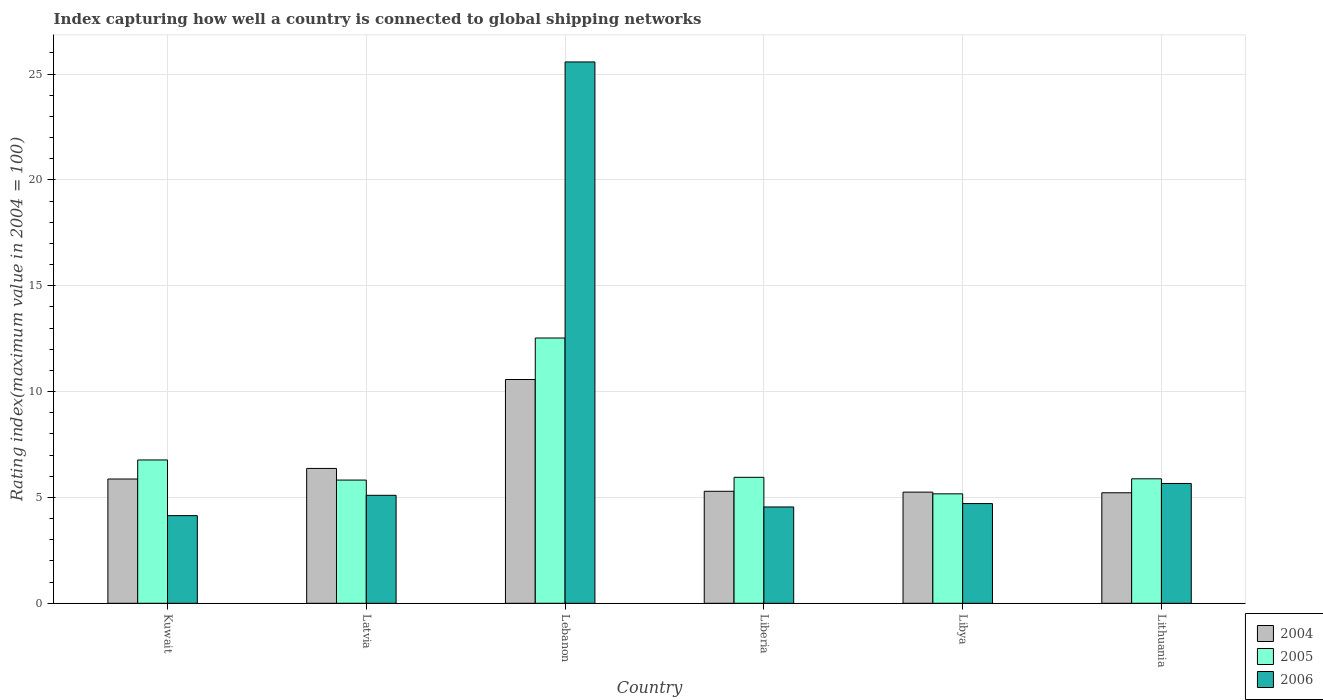How many different coloured bars are there?
Provide a short and direct response. 3. How many bars are there on the 1st tick from the left?
Make the answer very short. 3. What is the label of the 5th group of bars from the left?
Provide a short and direct response. Libya. In how many cases, is the number of bars for a given country not equal to the number of legend labels?
Give a very brief answer. 0. What is the rating index in 2005 in Lithuania?
Your answer should be compact. 5.88. Across all countries, what is the maximum rating index in 2006?
Your answer should be very brief. 25.57. Across all countries, what is the minimum rating index in 2006?
Give a very brief answer. 4.14. In which country was the rating index in 2006 maximum?
Give a very brief answer. Lebanon. In which country was the rating index in 2004 minimum?
Provide a short and direct response. Lithuania. What is the total rating index in 2004 in the graph?
Your answer should be very brief. 38.57. What is the difference between the rating index in 2004 in Kuwait and that in Lithuania?
Provide a succinct answer. 0.65. What is the difference between the rating index in 2004 in Lithuania and the rating index in 2005 in Lebanon?
Keep it short and to the point. -7.31. What is the average rating index in 2005 per country?
Offer a terse response. 7.02. What is the difference between the rating index of/in 2005 and rating index of/in 2006 in Liberia?
Your response must be concise. 1.4. What is the ratio of the rating index in 2006 in Kuwait to that in Latvia?
Ensure brevity in your answer.  0.81. What is the difference between the highest and the lowest rating index in 2005?
Offer a terse response. 7.36. In how many countries, is the rating index in 2004 greater than the average rating index in 2004 taken over all countries?
Provide a short and direct response. 1. Is the sum of the rating index in 2004 in Kuwait and Lebanon greater than the maximum rating index in 2005 across all countries?
Offer a terse response. Yes. What does the 3rd bar from the right in Latvia represents?
Your answer should be compact. 2004. How many bars are there?
Keep it short and to the point. 18. Are all the bars in the graph horizontal?
Your response must be concise. No. What is the difference between two consecutive major ticks on the Y-axis?
Keep it short and to the point. 5. Are the values on the major ticks of Y-axis written in scientific E-notation?
Offer a very short reply. No. How many legend labels are there?
Offer a very short reply. 3. What is the title of the graph?
Offer a very short reply. Index capturing how well a country is connected to global shipping networks. What is the label or title of the Y-axis?
Keep it short and to the point. Rating index(maximum value in 2004 = 100). What is the Rating index(maximum value in 2004 = 100) in 2004 in Kuwait?
Your answer should be compact. 5.87. What is the Rating index(maximum value in 2004 = 100) of 2005 in Kuwait?
Your answer should be very brief. 6.77. What is the Rating index(maximum value in 2004 = 100) of 2006 in Kuwait?
Ensure brevity in your answer.  4.14. What is the Rating index(maximum value in 2004 = 100) in 2004 in Latvia?
Your answer should be very brief. 6.37. What is the Rating index(maximum value in 2004 = 100) in 2005 in Latvia?
Your answer should be very brief. 5.82. What is the Rating index(maximum value in 2004 = 100) in 2004 in Lebanon?
Offer a terse response. 10.57. What is the Rating index(maximum value in 2004 = 100) in 2005 in Lebanon?
Offer a very short reply. 12.53. What is the Rating index(maximum value in 2004 = 100) of 2006 in Lebanon?
Your answer should be very brief. 25.57. What is the Rating index(maximum value in 2004 = 100) in 2004 in Liberia?
Offer a very short reply. 5.29. What is the Rating index(maximum value in 2004 = 100) of 2005 in Liberia?
Provide a short and direct response. 5.95. What is the Rating index(maximum value in 2004 = 100) of 2006 in Liberia?
Your answer should be very brief. 4.55. What is the Rating index(maximum value in 2004 = 100) of 2004 in Libya?
Ensure brevity in your answer.  5.25. What is the Rating index(maximum value in 2004 = 100) of 2005 in Libya?
Offer a terse response. 5.17. What is the Rating index(maximum value in 2004 = 100) in 2006 in Libya?
Provide a short and direct response. 4.71. What is the Rating index(maximum value in 2004 = 100) of 2004 in Lithuania?
Give a very brief answer. 5.22. What is the Rating index(maximum value in 2004 = 100) in 2005 in Lithuania?
Offer a very short reply. 5.88. What is the Rating index(maximum value in 2004 = 100) of 2006 in Lithuania?
Ensure brevity in your answer.  5.66. Across all countries, what is the maximum Rating index(maximum value in 2004 = 100) in 2004?
Provide a short and direct response. 10.57. Across all countries, what is the maximum Rating index(maximum value in 2004 = 100) of 2005?
Ensure brevity in your answer.  12.53. Across all countries, what is the maximum Rating index(maximum value in 2004 = 100) of 2006?
Your answer should be compact. 25.57. Across all countries, what is the minimum Rating index(maximum value in 2004 = 100) in 2004?
Your answer should be very brief. 5.22. Across all countries, what is the minimum Rating index(maximum value in 2004 = 100) of 2005?
Offer a terse response. 5.17. Across all countries, what is the minimum Rating index(maximum value in 2004 = 100) of 2006?
Ensure brevity in your answer.  4.14. What is the total Rating index(maximum value in 2004 = 100) in 2004 in the graph?
Keep it short and to the point. 38.57. What is the total Rating index(maximum value in 2004 = 100) of 2005 in the graph?
Your answer should be very brief. 42.12. What is the total Rating index(maximum value in 2004 = 100) of 2006 in the graph?
Your response must be concise. 49.73. What is the difference between the Rating index(maximum value in 2004 = 100) of 2005 in Kuwait and that in Latvia?
Your answer should be compact. 0.95. What is the difference between the Rating index(maximum value in 2004 = 100) in 2006 in Kuwait and that in Latvia?
Offer a terse response. -0.96. What is the difference between the Rating index(maximum value in 2004 = 100) of 2004 in Kuwait and that in Lebanon?
Give a very brief answer. -4.7. What is the difference between the Rating index(maximum value in 2004 = 100) of 2005 in Kuwait and that in Lebanon?
Give a very brief answer. -5.76. What is the difference between the Rating index(maximum value in 2004 = 100) of 2006 in Kuwait and that in Lebanon?
Give a very brief answer. -21.43. What is the difference between the Rating index(maximum value in 2004 = 100) in 2004 in Kuwait and that in Liberia?
Keep it short and to the point. 0.58. What is the difference between the Rating index(maximum value in 2004 = 100) of 2005 in Kuwait and that in Liberia?
Offer a very short reply. 0.82. What is the difference between the Rating index(maximum value in 2004 = 100) of 2006 in Kuwait and that in Liberia?
Make the answer very short. -0.41. What is the difference between the Rating index(maximum value in 2004 = 100) in 2004 in Kuwait and that in Libya?
Offer a very short reply. 0.62. What is the difference between the Rating index(maximum value in 2004 = 100) of 2005 in Kuwait and that in Libya?
Your response must be concise. 1.6. What is the difference between the Rating index(maximum value in 2004 = 100) of 2006 in Kuwait and that in Libya?
Ensure brevity in your answer.  -0.57. What is the difference between the Rating index(maximum value in 2004 = 100) of 2004 in Kuwait and that in Lithuania?
Offer a terse response. 0.65. What is the difference between the Rating index(maximum value in 2004 = 100) in 2005 in Kuwait and that in Lithuania?
Offer a terse response. 0.89. What is the difference between the Rating index(maximum value in 2004 = 100) of 2006 in Kuwait and that in Lithuania?
Offer a very short reply. -1.52. What is the difference between the Rating index(maximum value in 2004 = 100) of 2005 in Latvia and that in Lebanon?
Your answer should be compact. -6.71. What is the difference between the Rating index(maximum value in 2004 = 100) of 2006 in Latvia and that in Lebanon?
Offer a terse response. -20.47. What is the difference between the Rating index(maximum value in 2004 = 100) of 2005 in Latvia and that in Liberia?
Offer a terse response. -0.13. What is the difference between the Rating index(maximum value in 2004 = 100) of 2006 in Latvia and that in Liberia?
Your response must be concise. 0.55. What is the difference between the Rating index(maximum value in 2004 = 100) in 2004 in Latvia and that in Libya?
Your answer should be very brief. 1.12. What is the difference between the Rating index(maximum value in 2004 = 100) of 2005 in Latvia and that in Libya?
Your answer should be very brief. 0.65. What is the difference between the Rating index(maximum value in 2004 = 100) in 2006 in Latvia and that in Libya?
Your answer should be compact. 0.39. What is the difference between the Rating index(maximum value in 2004 = 100) of 2004 in Latvia and that in Lithuania?
Your response must be concise. 1.15. What is the difference between the Rating index(maximum value in 2004 = 100) of 2005 in Latvia and that in Lithuania?
Your response must be concise. -0.06. What is the difference between the Rating index(maximum value in 2004 = 100) of 2006 in Latvia and that in Lithuania?
Provide a short and direct response. -0.56. What is the difference between the Rating index(maximum value in 2004 = 100) in 2004 in Lebanon and that in Liberia?
Keep it short and to the point. 5.28. What is the difference between the Rating index(maximum value in 2004 = 100) in 2005 in Lebanon and that in Liberia?
Your response must be concise. 6.58. What is the difference between the Rating index(maximum value in 2004 = 100) in 2006 in Lebanon and that in Liberia?
Your response must be concise. 21.02. What is the difference between the Rating index(maximum value in 2004 = 100) of 2004 in Lebanon and that in Libya?
Give a very brief answer. 5.32. What is the difference between the Rating index(maximum value in 2004 = 100) in 2005 in Lebanon and that in Libya?
Your response must be concise. 7.36. What is the difference between the Rating index(maximum value in 2004 = 100) of 2006 in Lebanon and that in Libya?
Ensure brevity in your answer.  20.86. What is the difference between the Rating index(maximum value in 2004 = 100) of 2004 in Lebanon and that in Lithuania?
Provide a succinct answer. 5.35. What is the difference between the Rating index(maximum value in 2004 = 100) in 2005 in Lebanon and that in Lithuania?
Your response must be concise. 6.65. What is the difference between the Rating index(maximum value in 2004 = 100) in 2006 in Lebanon and that in Lithuania?
Your answer should be very brief. 19.91. What is the difference between the Rating index(maximum value in 2004 = 100) of 2005 in Liberia and that in Libya?
Keep it short and to the point. 0.78. What is the difference between the Rating index(maximum value in 2004 = 100) in 2006 in Liberia and that in Libya?
Your answer should be very brief. -0.16. What is the difference between the Rating index(maximum value in 2004 = 100) of 2004 in Liberia and that in Lithuania?
Offer a very short reply. 0.07. What is the difference between the Rating index(maximum value in 2004 = 100) in 2005 in Liberia and that in Lithuania?
Offer a terse response. 0.07. What is the difference between the Rating index(maximum value in 2004 = 100) of 2006 in Liberia and that in Lithuania?
Provide a succinct answer. -1.11. What is the difference between the Rating index(maximum value in 2004 = 100) in 2005 in Libya and that in Lithuania?
Ensure brevity in your answer.  -0.71. What is the difference between the Rating index(maximum value in 2004 = 100) in 2006 in Libya and that in Lithuania?
Offer a terse response. -0.95. What is the difference between the Rating index(maximum value in 2004 = 100) in 2004 in Kuwait and the Rating index(maximum value in 2004 = 100) in 2005 in Latvia?
Ensure brevity in your answer.  0.05. What is the difference between the Rating index(maximum value in 2004 = 100) of 2004 in Kuwait and the Rating index(maximum value in 2004 = 100) of 2006 in Latvia?
Your response must be concise. 0.77. What is the difference between the Rating index(maximum value in 2004 = 100) in 2005 in Kuwait and the Rating index(maximum value in 2004 = 100) in 2006 in Latvia?
Your response must be concise. 1.67. What is the difference between the Rating index(maximum value in 2004 = 100) of 2004 in Kuwait and the Rating index(maximum value in 2004 = 100) of 2005 in Lebanon?
Give a very brief answer. -6.66. What is the difference between the Rating index(maximum value in 2004 = 100) of 2004 in Kuwait and the Rating index(maximum value in 2004 = 100) of 2006 in Lebanon?
Your answer should be compact. -19.7. What is the difference between the Rating index(maximum value in 2004 = 100) in 2005 in Kuwait and the Rating index(maximum value in 2004 = 100) in 2006 in Lebanon?
Provide a succinct answer. -18.8. What is the difference between the Rating index(maximum value in 2004 = 100) in 2004 in Kuwait and the Rating index(maximum value in 2004 = 100) in 2005 in Liberia?
Give a very brief answer. -0.08. What is the difference between the Rating index(maximum value in 2004 = 100) of 2004 in Kuwait and the Rating index(maximum value in 2004 = 100) of 2006 in Liberia?
Offer a terse response. 1.32. What is the difference between the Rating index(maximum value in 2004 = 100) of 2005 in Kuwait and the Rating index(maximum value in 2004 = 100) of 2006 in Liberia?
Give a very brief answer. 2.22. What is the difference between the Rating index(maximum value in 2004 = 100) of 2004 in Kuwait and the Rating index(maximum value in 2004 = 100) of 2006 in Libya?
Provide a short and direct response. 1.16. What is the difference between the Rating index(maximum value in 2004 = 100) of 2005 in Kuwait and the Rating index(maximum value in 2004 = 100) of 2006 in Libya?
Provide a short and direct response. 2.06. What is the difference between the Rating index(maximum value in 2004 = 100) of 2004 in Kuwait and the Rating index(maximum value in 2004 = 100) of 2005 in Lithuania?
Keep it short and to the point. -0.01. What is the difference between the Rating index(maximum value in 2004 = 100) in 2004 in Kuwait and the Rating index(maximum value in 2004 = 100) in 2006 in Lithuania?
Provide a succinct answer. 0.21. What is the difference between the Rating index(maximum value in 2004 = 100) in 2005 in Kuwait and the Rating index(maximum value in 2004 = 100) in 2006 in Lithuania?
Ensure brevity in your answer.  1.11. What is the difference between the Rating index(maximum value in 2004 = 100) of 2004 in Latvia and the Rating index(maximum value in 2004 = 100) of 2005 in Lebanon?
Keep it short and to the point. -6.16. What is the difference between the Rating index(maximum value in 2004 = 100) of 2004 in Latvia and the Rating index(maximum value in 2004 = 100) of 2006 in Lebanon?
Provide a succinct answer. -19.2. What is the difference between the Rating index(maximum value in 2004 = 100) of 2005 in Latvia and the Rating index(maximum value in 2004 = 100) of 2006 in Lebanon?
Keep it short and to the point. -19.75. What is the difference between the Rating index(maximum value in 2004 = 100) in 2004 in Latvia and the Rating index(maximum value in 2004 = 100) in 2005 in Liberia?
Provide a short and direct response. 0.42. What is the difference between the Rating index(maximum value in 2004 = 100) in 2004 in Latvia and the Rating index(maximum value in 2004 = 100) in 2006 in Liberia?
Offer a terse response. 1.82. What is the difference between the Rating index(maximum value in 2004 = 100) of 2005 in Latvia and the Rating index(maximum value in 2004 = 100) of 2006 in Liberia?
Offer a terse response. 1.27. What is the difference between the Rating index(maximum value in 2004 = 100) of 2004 in Latvia and the Rating index(maximum value in 2004 = 100) of 2006 in Libya?
Provide a short and direct response. 1.66. What is the difference between the Rating index(maximum value in 2004 = 100) in 2005 in Latvia and the Rating index(maximum value in 2004 = 100) in 2006 in Libya?
Provide a short and direct response. 1.11. What is the difference between the Rating index(maximum value in 2004 = 100) of 2004 in Latvia and the Rating index(maximum value in 2004 = 100) of 2005 in Lithuania?
Make the answer very short. 0.49. What is the difference between the Rating index(maximum value in 2004 = 100) of 2004 in Latvia and the Rating index(maximum value in 2004 = 100) of 2006 in Lithuania?
Provide a succinct answer. 0.71. What is the difference between the Rating index(maximum value in 2004 = 100) in 2005 in Latvia and the Rating index(maximum value in 2004 = 100) in 2006 in Lithuania?
Offer a very short reply. 0.16. What is the difference between the Rating index(maximum value in 2004 = 100) of 2004 in Lebanon and the Rating index(maximum value in 2004 = 100) of 2005 in Liberia?
Make the answer very short. 4.62. What is the difference between the Rating index(maximum value in 2004 = 100) in 2004 in Lebanon and the Rating index(maximum value in 2004 = 100) in 2006 in Liberia?
Your answer should be compact. 6.02. What is the difference between the Rating index(maximum value in 2004 = 100) of 2005 in Lebanon and the Rating index(maximum value in 2004 = 100) of 2006 in Liberia?
Make the answer very short. 7.98. What is the difference between the Rating index(maximum value in 2004 = 100) in 2004 in Lebanon and the Rating index(maximum value in 2004 = 100) in 2006 in Libya?
Provide a succinct answer. 5.86. What is the difference between the Rating index(maximum value in 2004 = 100) of 2005 in Lebanon and the Rating index(maximum value in 2004 = 100) of 2006 in Libya?
Ensure brevity in your answer.  7.82. What is the difference between the Rating index(maximum value in 2004 = 100) in 2004 in Lebanon and the Rating index(maximum value in 2004 = 100) in 2005 in Lithuania?
Provide a succinct answer. 4.69. What is the difference between the Rating index(maximum value in 2004 = 100) of 2004 in Lebanon and the Rating index(maximum value in 2004 = 100) of 2006 in Lithuania?
Your answer should be very brief. 4.91. What is the difference between the Rating index(maximum value in 2004 = 100) of 2005 in Lebanon and the Rating index(maximum value in 2004 = 100) of 2006 in Lithuania?
Give a very brief answer. 6.87. What is the difference between the Rating index(maximum value in 2004 = 100) in 2004 in Liberia and the Rating index(maximum value in 2004 = 100) in 2005 in Libya?
Your answer should be very brief. 0.12. What is the difference between the Rating index(maximum value in 2004 = 100) in 2004 in Liberia and the Rating index(maximum value in 2004 = 100) in 2006 in Libya?
Provide a short and direct response. 0.58. What is the difference between the Rating index(maximum value in 2004 = 100) of 2005 in Liberia and the Rating index(maximum value in 2004 = 100) of 2006 in Libya?
Keep it short and to the point. 1.24. What is the difference between the Rating index(maximum value in 2004 = 100) in 2004 in Liberia and the Rating index(maximum value in 2004 = 100) in 2005 in Lithuania?
Provide a succinct answer. -0.59. What is the difference between the Rating index(maximum value in 2004 = 100) in 2004 in Liberia and the Rating index(maximum value in 2004 = 100) in 2006 in Lithuania?
Ensure brevity in your answer.  -0.37. What is the difference between the Rating index(maximum value in 2004 = 100) in 2005 in Liberia and the Rating index(maximum value in 2004 = 100) in 2006 in Lithuania?
Make the answer very short. 0.29. What is the difference between the Rating index(maximum value in 2004 = 100) of 2004 in Libya and the Rating index(maximum value in 2004 = 100) of 2005 in Lithuania?
Make the answer very short. -0.63. What is the difference between the Rating index(maximum value in 2004 = 100) in 2004 in Libya and the Rating index(maximum value in 2004 = 100) in 2006 in Lithuania?
Offer a terse response. -0.41. What is the difference between the Rating index(maximum value in 2004 = 100) of 2005 in Libya and the Rating index(maximum value in 2004 = 100) of 2006 in Lithuania?
Provide a short and direct response. -0.49. What is the average Rating index(maximum value in 2004 = 100) in 2004 per country?
Provide a short and direct response. 6.43. What is the average Rating index(maximum value in 2004 = 100) of 2005 per country?
Provide a short and direct response. 7.02. What is the average Rating index(maximum value in 2004 = 100) in 2006 per country?
Ensure brevity in your answer.  8.29. What is the difference between the Rating index(maximum value in 2004 = 100) in 2004 and Rating index(maximum value in 2004 = 100) in 2006 in Kuwait?
Offer a terse response. 1.73. What is the difference between the Rating index(maximum value in 2004 = 100) in 2005 and Rating index(maximum value in 2004 = 100) in 2006 in Kuwait?
Your answer should be compact. 2.63. What is the difference between the Rating index(maximum value in 2004 = 100) in 2004 and Rating index(maximum value in 2004 = 100) in 2005 in Latvia?
Your response must be concise. 0.55. What is the difference between the Rating index(maximum value in 2004 = 100) of 2004 and Rating index(maximum value in 2004 = 100) of 2006 in Latvia?
Provide a succinct answer. 1.27. What is the difference between the Rating index(maximum value in 2004 = 100) in 2005 and Rating index(maximum value in 2004 = 100) in 2006 in Latvia?
Your answer should be compact. 0.72. What is the difference between the Rating index(maximum value in 2004 = 100) in 2004 and Rating index(maximum value in 2004 = 100) in 2005 in Lebanon?
Keep it short and to the point. -1.96. What is the difference between the Rating index(maximum value in 2004 = 100) in 2004 and Rating index(maximum value in 2004 = 100) in 2006 in Lebanon?
Your answer should be very brief. -15. What is the difference between the Rating index(maximum value in 2004 = 100) in 2005 and Rating index(maximum value in 2004 = 100) in 2006 in Lebanon?
Your answer should be very brief. -13.04. What is the difference between the Rating index(maximum value in 2004 = 100) of 2004 and Rating index(maximum value in 2004 = 100) of 2005 in Liberia?
Your answer should be very brief. -0.66. What is the difference between the Rating index(maximum value in 2004 = 100) of 2004 and Rating index(maximum value in 2004 = 100) of 2006 in Liberia?
Provide a succinct answer. 0.74. What is the difference between the Rating index(maximum value in 2004 = 100) of 2005 and Rating index(maximum value in 2004 = 100) of 2006 in Liberia?
Provide a short and direct response. 1.4. What is the difference between the Rating index(maximum value in 2004 = 100) of 2004 and Rating index(maximum value in 2004 = 100) of 2005 in Libya?
Ensure brevity in your answer.  0.08. What is the difference between the Rating index(maximum value in 2004 = 100) in 2004 and Rating index(maximum value in 2004 = 100) in 2006 in Libya?
Offer a very short reply. 0.54. What is the difference between the Rating index(maximum value in 2004 = 100) in 2005 and Rating index(maximum value in 2004 = 100) in 2006 in Libya?
Your response must be concise. 0.46. What is the difference between the Rating index(maximum value in 2004 = 100) of 2004 and Rating index(maximum value in 2004 = 100) of 2005 in Lithuania?
Make the answer very short. -0.66. What is the difference between the Rating index(maximum value in 2004 = 100) in 2004 and Rating index(maximum value in 2004 = 100) in 2006 in Lithuania?
Make the answer very short. -0.44. What is the difference between the Rating index(maximum value in 2004 = 100) of 2005 and Rating index(maximum value in 2004 = 100) of 2006 in Lithuania?
Offer a terse response. 0.22. What is the ratio of the Rating index(maximum value in 2004 = 100) of 2004 in Kuwait to that in Latvia?
Keep it short and to the point. 0.92. What is the ratio of the Rating index(maximum value in 2004 = 100) of 2005 in Kuwait to that in Latvia?
Ensure brevity in your answer.  1.16. What is the ratio of the Rating index(maximum value in 2004 = 100) in 2006 in Kuwait to that in Latvia?
Provide a short and direct response. 0.81. What is the ratio of the Rating index(maximum value in 2004 = 100) of 2004 in Kuwait to that in Lebanon?
Make the answer very short. 0.56. What is the ratio of the Rating index(maximum value in 2004 = 100) in 2005 in Kuwait to that in Lebanon?
Give a very brief answer. 0.54. What is the ratio of the Rating index(maximum value in 2004 = 100) in 2006 in Kuwait to that in Lebanon?
Your response must be concise. 0.16. What is the ratio of the Rating index(maximum value in 2004 = 100) of 2004 in Kuwait to that in Liberia?
Your answer should be compact. 1.11. What is the ratio of the Rating index(maximum value in 2004 = 100) of 2005 in Kuwait to that in Liberia?
Make the answer very short. 1.14. What is the ratio of the Rating index(maximum value in 2004 = 100) in 2006 in Kuwait to that in Liberia?
Your response must be concise. 0.91. What is the ratio of the Rating index(maximum value in 2004 = 100) of 2004 in Kuwait to that in Libya?
Provide a succinct answer. 1.12. What is the ratio of the Rating index(maximum value in 2004 = 100) in 2005 in Kuwait to that in Libya?
Your answer should be very brief. 1.31. What is the ratio of the Rating index(maximum value in 2004 = 100) of 2006 in Kuwait to that in Libya?
Keep it short and to the point. 0.88. What is the ratio of the Rating index(maximum value in 2004 = 100) of 2004 in Kuwait to that in Lithuania?
Give a very brief answer. 1.12. What is the ratio of the Rating index(maximum value in 2004 = 100) of 2005 in Kuwait to that in Lithuania?
Provide a succinct answer. 1.15. What is the ratio of the Rating index(maximum value in 2004 = 100) of 2006 in Kuwait to that in Lithuania?
Give a very brief answer. 0.73. What is the ratio of the Rating index(maximum value in 2004 = 100) in 2004 in Latvia to that in Lebanon?
Make the answer very short. 0.6. What is the ratio of the Rating index(maximum value in 2004 = 100) in 2005 in Latvia to that in Lebanon?
Keep it short and to the point. 0.46. What is the ratio of the Rating index(maximum value in 2004 = 100) of 2006 in Latvia to that in Lebanon?
Give a very brief answer. 0.2. What is the ratio of the Rating index(maximum value in 2004 = 100) of 2004 in Latvia to that in Liberia?
Ensure brevity in your answer.  1.2. What is the ratio of the Rating index(maximum value in 2004 = 100) in 2005 in Latvia to that in Liberia?
Your answer should be compact. 0.98. What is the ratio of the Rating index(maximum value in 2004 = 100) in 2006 in Latvia to that in Liberia?
Keep it short and to the point. 1.12. What is the ratio of the Rating index(maximum value in 2004 = 100) in 2004 in Latvia to that in Libya?
Your answer should be very brief. 1.21. What is the ratio of the Rating index(maximum value in 2004 = 100) of 2005 in Latvia to that in Libya?
Keep it short and to the point. 1.13. What is the ratio of the Rating index(maximum value in 2004 = 100) in 2006 in Latvia to that in Libya?
Your response must be concise. 1.08. What is the ratio of the Rating index(maximum value in 2004 = 100) of 2004 in Latvia to that in Lithuania?
Your response must be concise. 1.22. What is the ratio of the Rating index(maximum value in 2004 = 100) of 2006 in Latvia to that in Lithuania?
Offer a very short reply. 0.9. What is the ratio of the Rating index(maximum value in 2004 = 100) in 2004 in Lebanon to that in Liberia?
Offer a terse response. 2. What is the ratio of the Rating index(maximum value in 2004 = 100) of 2005 in Lebanon to that in Liberia?
Provide a short and direct response. 2.11. What is the ratio of the Rating index(maximum value in 2004 = 100) of 2006 in Lebanon to that in Liberia?
Your answer should be compact. 5.62. What is the ratio of the Rating index(maximum value in 2004 = 100) in 2004 in Lebanon to that in Libya?
Offer a very short reply. 2.01. What is the ratio of the Rating index(maximum value in 2004 = 100) in 2005 in Lebanon to that in Libya?
Your answer should be very brief. 2.42. What is the ratio of the Rating index(maximum value in 2004 = 100) in 2006 in Lebanon to that in Libya?
Make the answer very short. 5.43. What is the ratio of the Rating index(maximum value in 2004 = 100) in 2004 in Lebanon to that in Lithuania?
Ensure brevity in your answer.  2.02. What is the ratio of the Rating index(maximum value in 2004 = 100) of 2005 in Lebanon to that in Lithuania?
Keep it short and to the point. 2.13. What is the ratio of the Rating index(maximum value in 2004 = 100) in 2006 in Lebanon to that in Lithuania?
Your answer should be very brief. 4.52. What is the ratio of the Rating index(maximum value in 2004 = 100) of 2004 in Liberia to that in Libya?
Your response must be concise. 1.01. What is the ratio of the Rating index(maximum value in 2004 = 100) in 2005 in Liberia to that in Libya?
Offer a very short reply. 1.15. What is the ratio of the Rating index(maximum value in 2004 = 100) in 2004 in Liberia to that in Lithuania?
Give a very brief answer. 1.01. What is the ratio of the Rating index(maximum value in 2004 = 100) in 2005 in Liberia to that in Lithuania?
Provide a short and direct response. 1.01. What is the ratio of the Rating index(maximum value in 2004 = 100) of 2006 in Liberia to that in Lithuania?
Offer a terse response. 0.8. What is the ratio of the Rating index(maximum value in 2004 = 100) in 2004 in Libya to that in Lithuania?
Offer a very short reply. 1.01. What is the ratio of the Rating index(maximum value in 2004 = 100) in 2005 in Libya to that in Lithuania?
Keep it short and to the point. 0.88. What is the ratio of the Rating index(maximum value in 2004 = 100) of 2006 in Libya to that in Lithuania?
Provide a succinct answer. 0.83. What is the difference between the highest and the second highest Rating index(maximum value in 2004 = 100) in 2005?
Your answer should be very brief. 5.76. What is the difference between the highest and the second highest Rating index(maximum value in 2004 = 100) of 2006?
Ensure brevity in your answer.  19.91. What is the difference between the highest and the lowest Rating index(maximum value in 2004 = 100) in 2004?
Ensure brevity in your answer.  5.35. What is the difference between the highest and the lowest Rating index(maximum value in 2004 = 100) in 2005?
Make the answer very short. 7.36. What is the difference between the highest and the lowest Rating index(maximum value in 2004 = 100) of 2006?
Your response must be concise. 21.43. 